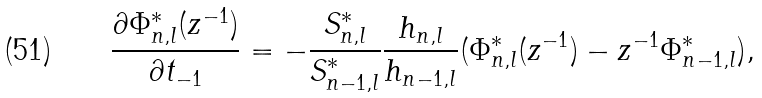Convert formula to latex. <formula><loc_0><loc_0><loc_500><loc_500>\frac { \partial \Phi _ { n , l } ^ { * } ( z ^ { - 1 } ) } { \partial t _ { - 1 } } = - \frac { S _ { n , l } ^ { * } } { S _ { n - 1 , l } ^ { * } } \frac { h _ { n , l } } { h _ { n - 1 , l } } ( \Phi _ { n , l } ^ { * } ( z ^ { - 1 } ) - z ^ { - 1 } \Phi _ { n - 1 , l } ^ { * } ) ,</formula> 